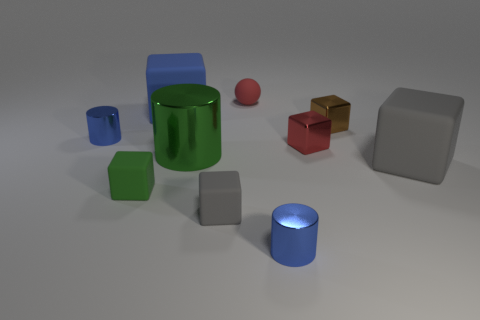Is there a matte thing that has the same color as the large metal thing?
Your answer should be very brief. Yes. Is the size of the gray thing that is in front of the big gray object the same as the green object to the right of the big blue thing?
Your answer should be very brief. No. The tiny block that is both right of the green block and in front of the large green shiny cylinder is made of what material?
Provide a short and direct response. Rubber. The metal object that is the same color as the matte sphere is what size?
Make the answer very short. Small. What number of other objects are there of the same size as the green matte thing?
Offer a very short reply. 6. There is a green cylinder behind the small gray rubber block; what is its material?
Offer a terse response. Metal. Do the red metallic object and the large blue thing have the same shape?
Ensure brevity in your answer.  Yes. How many other objects are there of the same shape as the big green object?
Make the answer very short. 2. There is a small rubber block that is to the right of the blue rubber thing; what is its color?
Give a very brief answer. Gray. Do the green metal cylinder and the blue rubber cube have the same size?
Provide a succinct answer. Yes. 